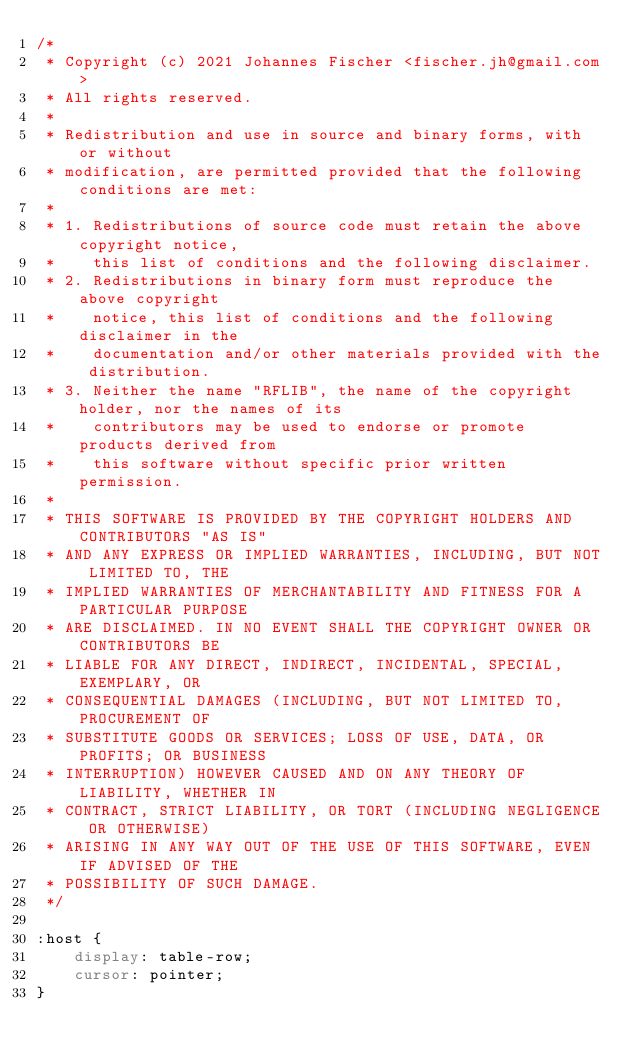<code> <loc_0><loc_0><loc_500><loc_500><_CSS_>/*
 * Copyright (c) 2021 Johannes Fischer <fischer.jh@gmail.com>
 * All rights reserved.
 *
 * Redistribution and use in source and binary forms, with or without
 * modification, are permitted provided that the following conditions are met:
 *
 * 1. Redistributions of source code must retain the above copyright notice,
 *    this list of conditions and the following disclaimer.
 * 2. Redistributions in binary form must reproduce the above copyright
 *    notice, this list of conditions and the following disclaimer in the
 *    documentation and/or other materials provided with the distribution.
 * 3. Neither the name "RFLIB", the name of the copyright holder, nor the names of its
 *    contributors may be used to endorse or promote products derived from
 *    this software without specific prior written permission.
 *
 * THIS SOFTWARE IS PROVIDED BY THE COPYRIGHT HOLDERS AND CONTRIBUTORS "AS IS"
 * AND ANY EXPRESS OR IMPLIED WARRANTIES, INCLUDING, BUT NOT LIMITED TO, THE
 * IMPLIED WARRANTIES OF MERCHANTABILITY AND FITNESS FOR A PARTICULAR PURPOSE
 * ARE DISCLAIMED. IN NO EVENT SHALL THE COPYRIGHT OWNER OR CONTRIBUTORS BE
 * LIABLE FOR ANY DIRECT, INDIRECT, INCIDENTAL, SPECIAL, EXEMPLARY, OR
 * CONSEQUENTIAL DAMAGES (INCLUDING, BUT NOT LIMITED TO, PROCUREMENT OF
 * SUBSTITUTE GOODS OR SERVICES; LOSS OF USE, DATA, OR PROFITS; OR BUSINESS
 * INTERRUPTION) HOWEVER CAUSED AND ON ANY THEORY OF LIABILITY, WHETHER IN
 * CONTRACT, STRICT LIABILITY, OR TORT (INCLUDING NEGLIGENCE OR OTHERWISE)
 * ARISING IN ANY WAY OUT OF THE USE OF THIS SOFTWARE, EVEN IF ADVISED OF THE
 * POSSIBILITY OF SUCH DAMAGE.
 */

:host {
    display: table-row;
    cursor: pointer;
}</code> 